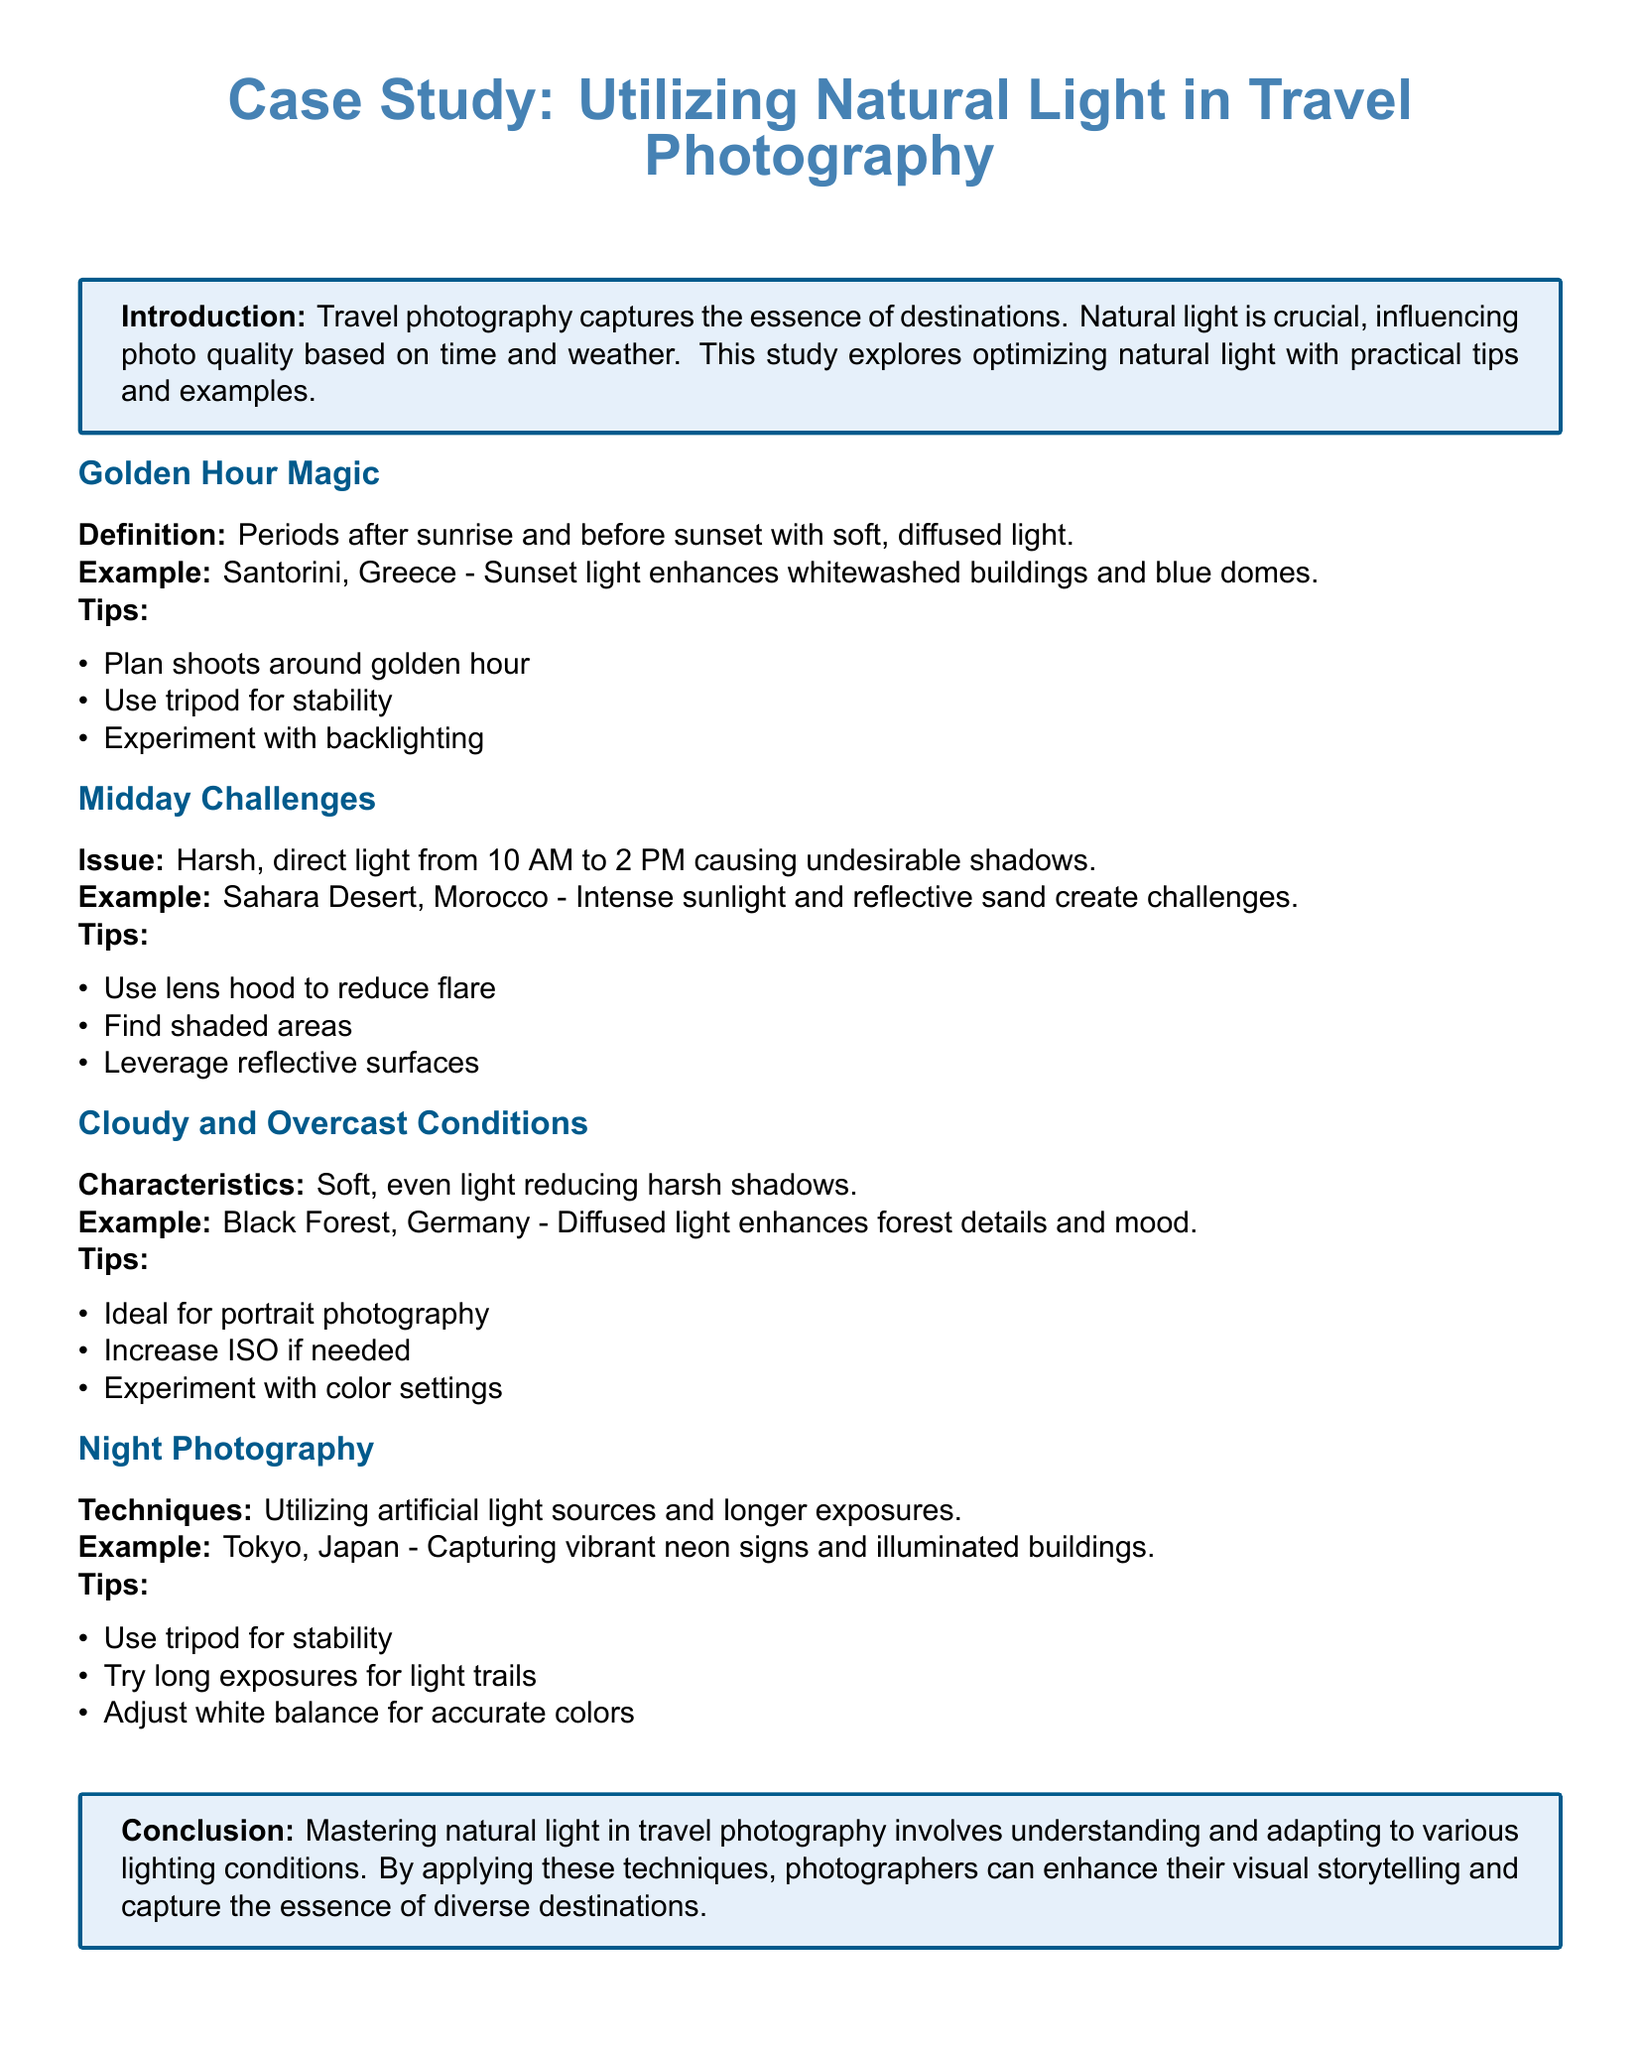What is the golden hour? The golden hour is defined as periods after sunrise and before sunset with soft, diffused light.
Answer: Periods after sunrise and before sunset What location is used as an example for golden hour photography? The case study provides Santorini, Greece, as an example of golden hour light enhancing its buildings.
Answer: Santorini, Greece What challenge is associated with midday photography? The document states that the issue with midday photography is harsh, direct light causing undesirable shadows.
Answer: Harsh, direct light What natural phenomenon is described as reducing harsh shadows? Cloudy and overcast conditions are characterized as reducing harsh shadows in photography.
Answer: Cloudy and overcast conditions What is a recommended technique for night photography? One of the tips for night photography is to use a tripod for stability.
Answer: Use tripod for stability How does the case study suggest to optimize light during midday? The document advises finding shaded areas to optimize lighting conditions during midday.
Answer: Find shaded areas What type of lighting is ideal for portrait photography, according to the study? The case study mentions that cloudy conditions provide ideal soft, even light for portrait photography.
Answer: Cloudy conditions What is one of the tips given for photographing in night conditions? The case study suggests trying long exposures for capturing light trails in night photography.
Answer: Try long exposures for light trails 